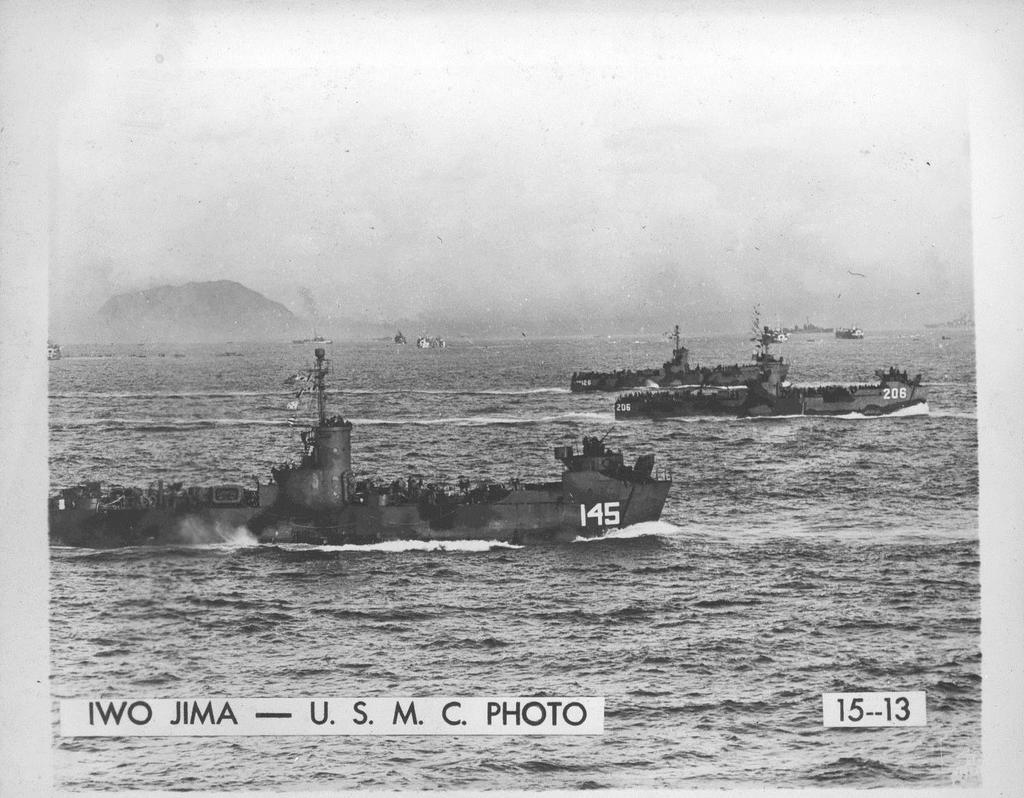Provide a one-sentence caption for the provided image. A black and white photo shows old battle ships from the United States Marine Core on the water. 